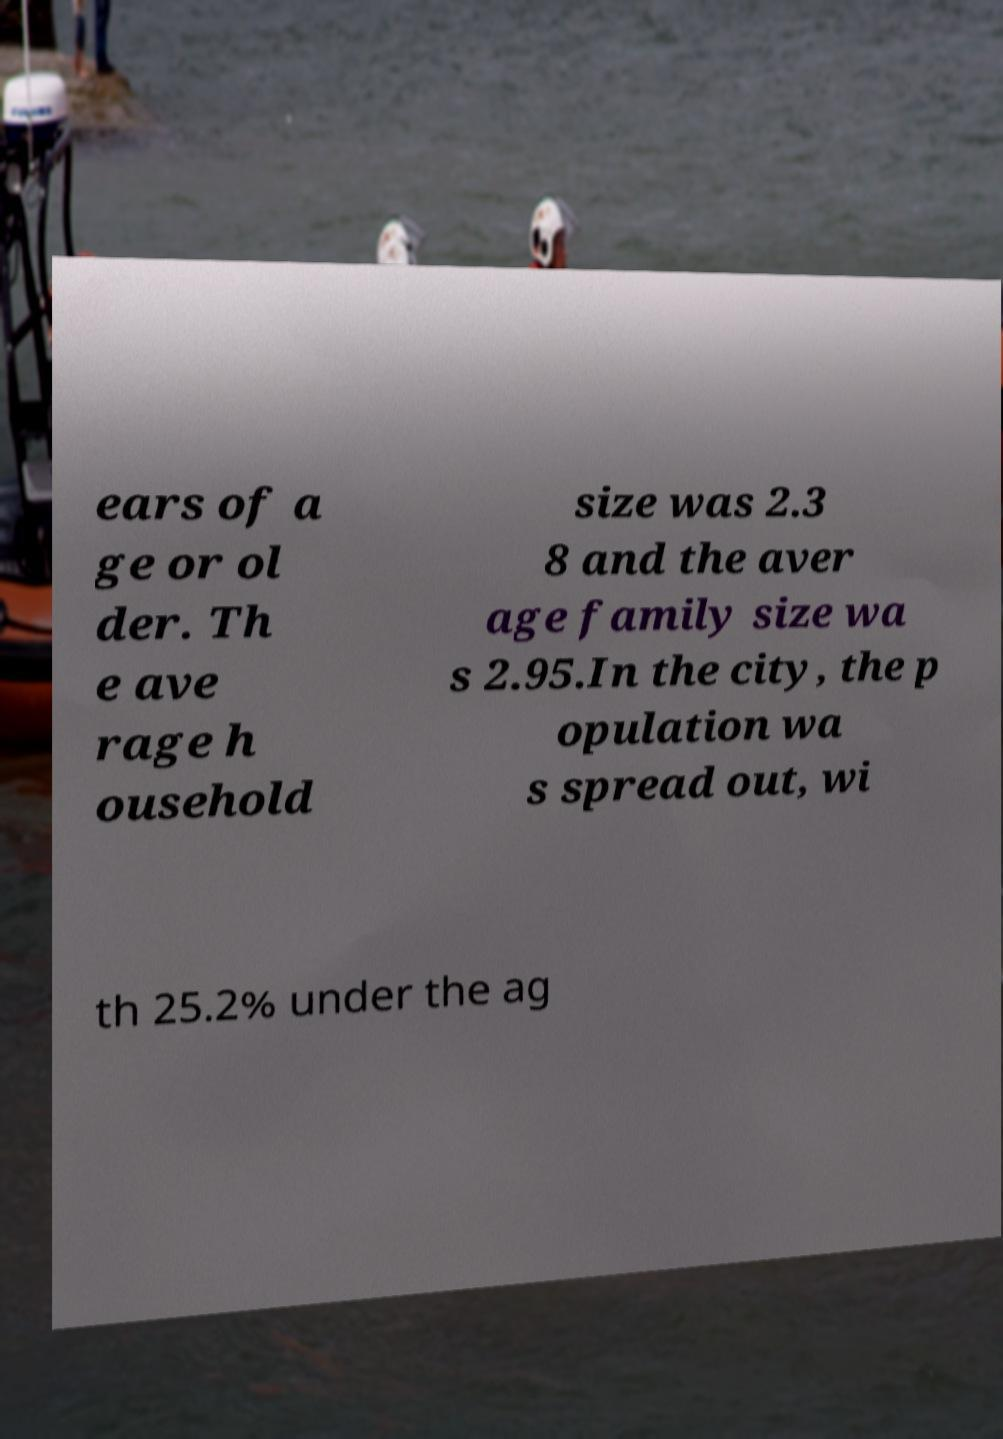Please identify and transcribe the text found in this image. ears of a ge or ol der. Th e ave rage h ousehold size was 2.3 8 and the aver age family size wa s 2.95.In the city, the p opulation wa s spread out, wi th 25.2% under the ag 